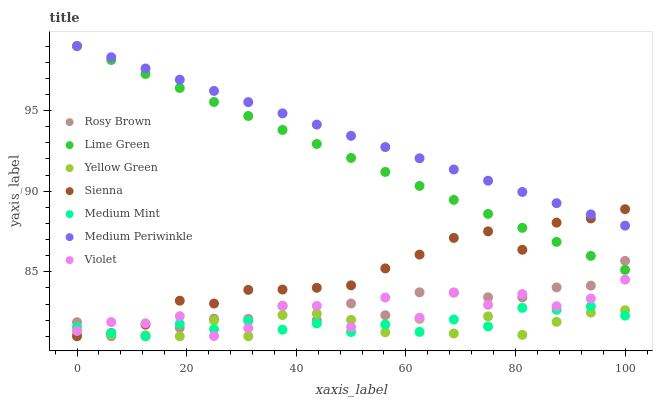Does Yellow Green have the minimum area under the curve?
Answer yes or no. Yes. Does Medium Periwinkle have the maximum area under the curve?
Answer yes or no. Yes. Does Rosy Brown have the minimum area under the curve?
Answer yes or no. No. Does Rosy Brown have the maximum area under the curve?
Answer yes or no. No. Is Lime Green the smoothest?
Answer yes or no. Yes. Is Violet the roughest?
Answer yes or no. Yes. Is Yellow Green the smoothest?
Answer yes or no. No. Is Yellow Green the roughest?
Answer yes or no. No. Does Medium Mint have the lowest value?
Answer yes or no. Yes. Does Medium Periwinkle have the lowest value?
Answer yes or no. No. Does Lime Green have the highest value?
Answer yes or no. Yes. Does Rosy Brown have the highest value?
Answer yes or no. No. Is Violet less than Lime Green?
Answer yes or no. Yes. Is Medium Periwinkle greater than Yellow Green?
Answer yes or no. Yes. Does Rosy Brown intersect Sienna?
Answer yes or no. Yes. Is Rosy Brown less than Sienna?
Answer yes or no. No. Is Rosy Brown greater than Sienna?
Answer yes or no. No. Does Violet intersect Lime Green?
Answer yes or no. No. 